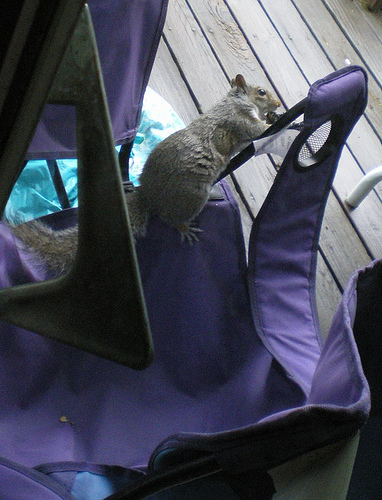<image>
Can you confirm if the squirrel is to the left of the chair? No. The squirrel is not to the left of the chair. From this viewpoint, they have a different horizontal relationship. 